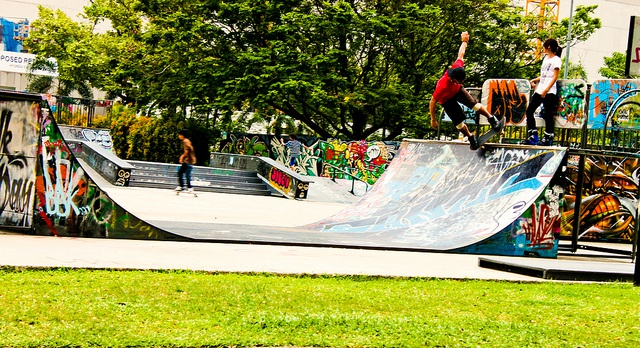Describe the objects in this image and their specific colors. I can see people in ivory, black, maroon, and red tones, people in ivory, black, white, olive, and maroon tones, people in ivory, black, brown, maroon, and red tones, people in ivory, black, and gray tones, and skateboard in ivory, black, and gray tones in this image. 